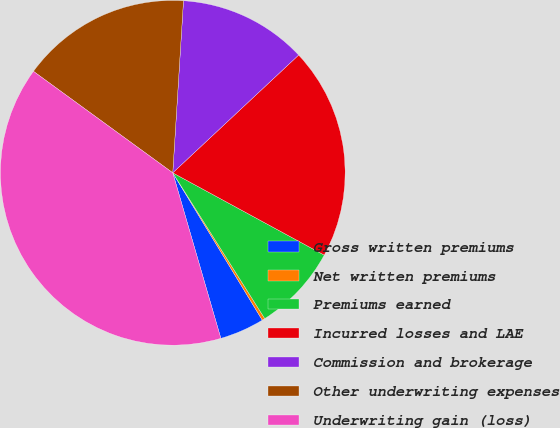<chart> <loc_0><loc_0><loc_500><loc_500><pie_chart><fcel>Gross written premiums<fcel>Net written premiums<fcel>Premiums earned<fcel>Incurred losses and LAE<fcel>Commission and brokerage<fcel>Other underwriting expenses<fcel>Underwriting gain (loss)<nl><fcel>4.19%<fcel>0.27%<fcel>8.12%<fcel>19.89%<fcel>12.04%<fcel>15.97%<fcel>39.52%<nl></chart> 